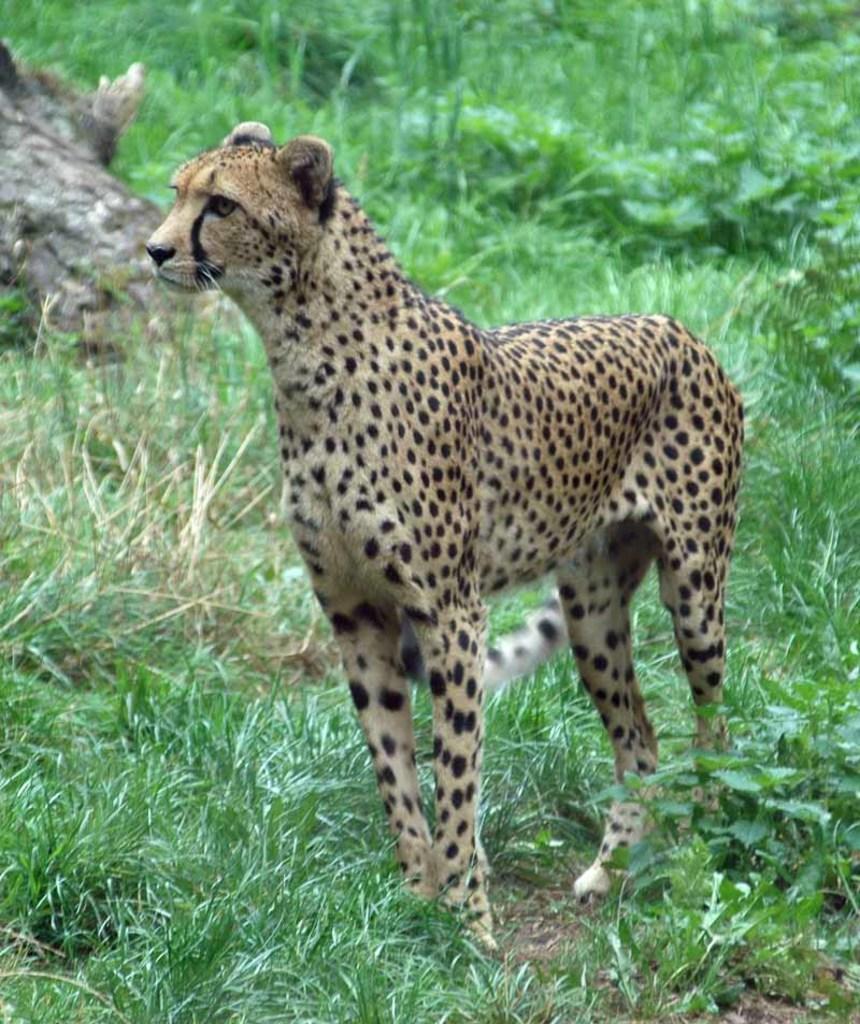Describe this image in one or two sentences. In this image I can see an animal which is in black and brown color. Background I can see plants and grass in green color. 